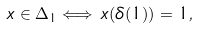<formula> <loc_0><loc_0><loc_500><loc_500>x \in \Delta _ { 1 } \Longleftrightarrow \, x ( \delta ( 1 ) ) = 1 ,</formula> 